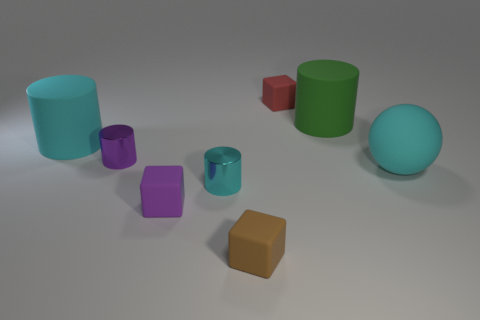What material is the cyan object that is in front of the big rubber sphere that is in front of the small matte object that is behind the cyan matte sphere?
Ensure brevity in your answer.  Metal. Are there more tiny matte blocks behind the large ball than purple metallic cylinders that are behind the small purple shiny object?
Your answer should be very brief. Yes. Is the size of the brown cube the same as the purple shiny object?
Keep it short and to the point. Yes. The other matte thing that is the same shape as the large green matte object is what color?
Offer a terse response. Cyan. What number of large matte cylinders are the same color as the big matte ball?
Your answer should be compact. 1. Are there more small purple metal cylinders that are behind the tiny purple metal object than brown matte blocks?
Your answer should be compact. No. There is a small rubber cube behind the cyan thing that is to the right of the brown rubber thing; what is its color?
Give a very brief answer. Red. What number of things are cubes behind the large cyan rubber cylinder or matte things that are left of the large green cylinder?
Your answer should be compact. 4. The big ball is what color?
Provide a succinct answer. Cyan. What number of brown objects have the same material as the large cyan cylinder?
Provide a short and direct response. 1. 